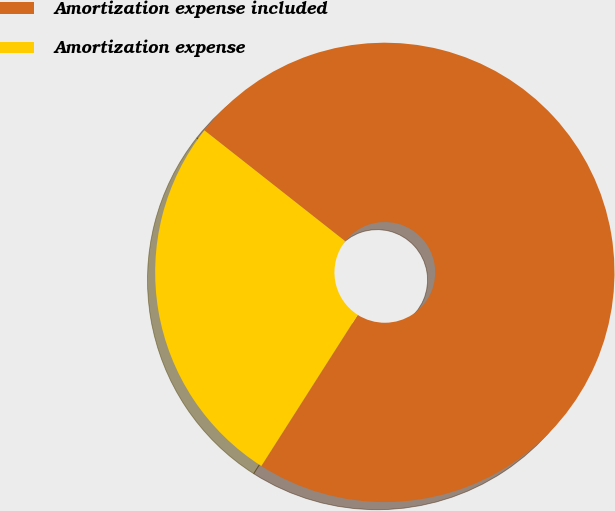Convert chart. <chart><loc_0><loc_0><loc_500><loc_500><pie_chart><fcel>Amortization expense included<fcel>Amortization expense<nl><fcel>73.42%<fcel>26.58%<nl></chart> 